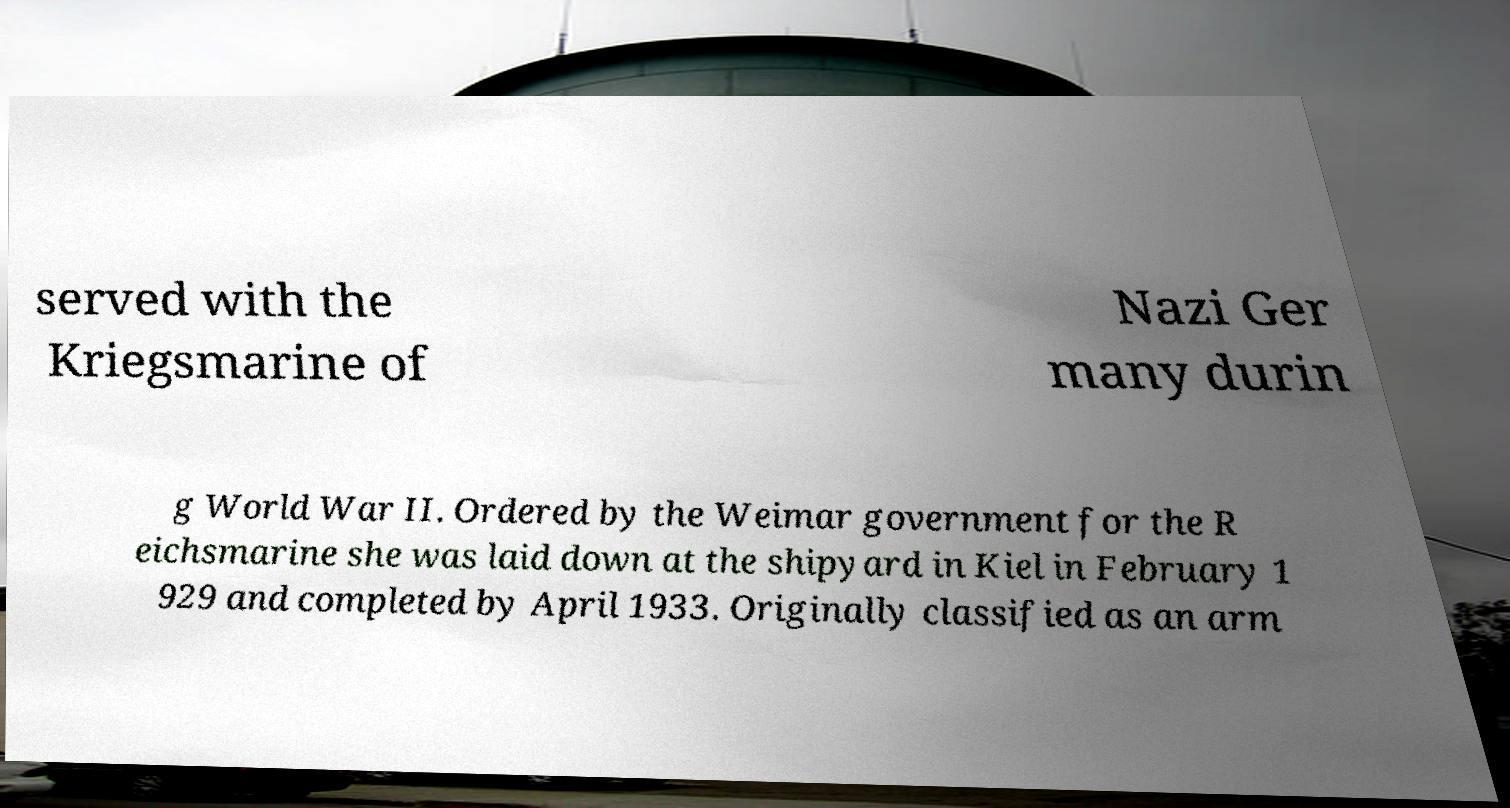For documentation purposes, I need the text within this image transcribed. Could you provide that? served with the Kriegsmarine of Nazi Ger many durin g World War II. Ordered by the Weimar government for the R eichsmarine she was laid down at the shipyard in Kiel in February 1 929 and completed by April 1933. Originally classified as an arm 